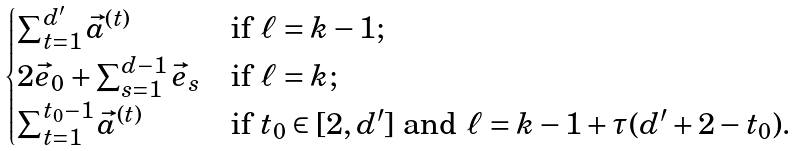<formula> <loc_0><loc_0><loc_500><loc_500>\begin{cases} \sum _ { t = 1 } ^ { d ^ { \prime } } \vec { a } ^ { ( t ) } & \text {if } \ell = k - 1 ; \\ 2 \vec { e } _ { 0 } + \sum _ { s = 1 } ^ { d - 1 } \vec { e } _ { s } & \text {if } \ell = k ; \\ \sum _ { t = 1 } ^ { t _ { 0 } - 1 } \vec { a } ^ { ( t ) } & \text {if } t _ { 0 } \in [ 2 , d ^ { \prime } ] \text { and } \ell = k - 1 + \tau ( d ^ { \prime } + 2 - t _ { 0 } ) . \end{cases}</formula> 